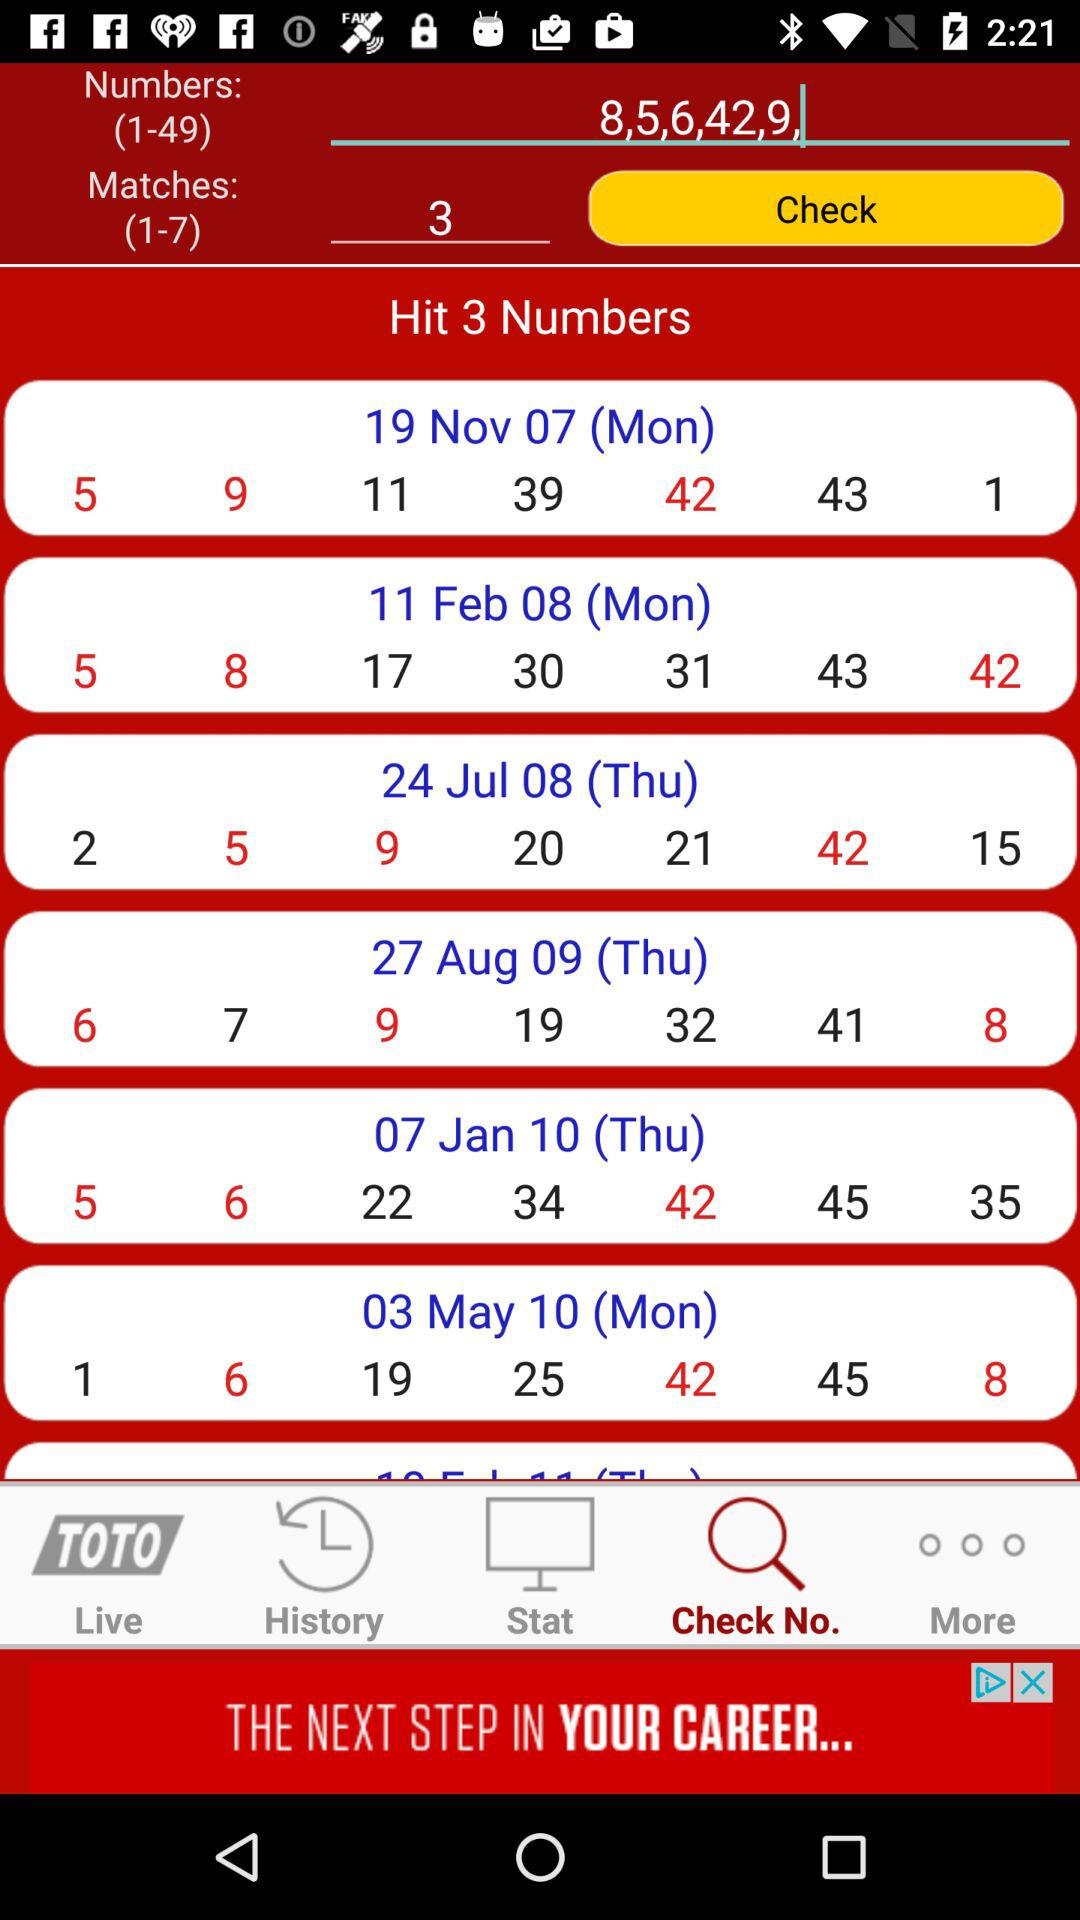How many numbers to hit? The number to be hit is 3. 